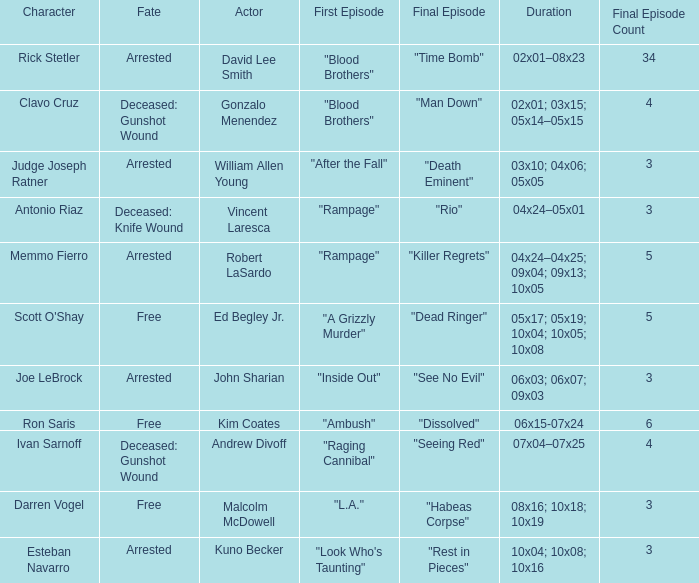What's the total number of final epbeingode count with first epbeingode being "l.a." 1.0. 